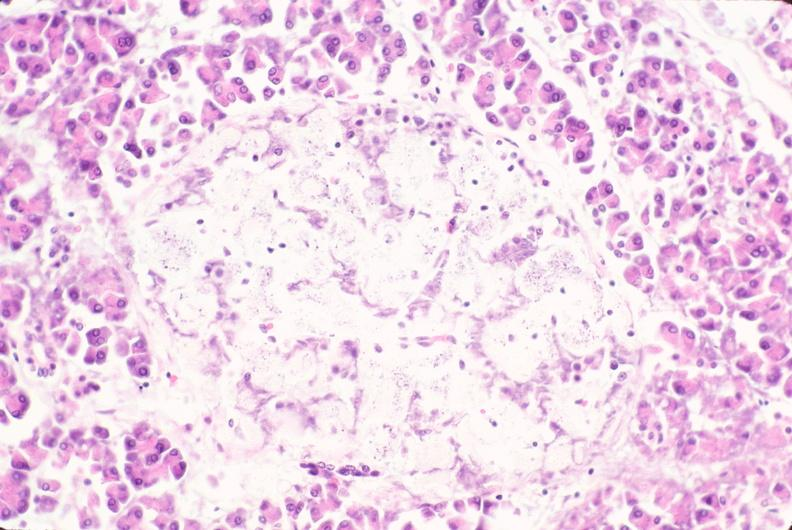what does this image show?
Answer the question using a single word or phrase. Pancreas 